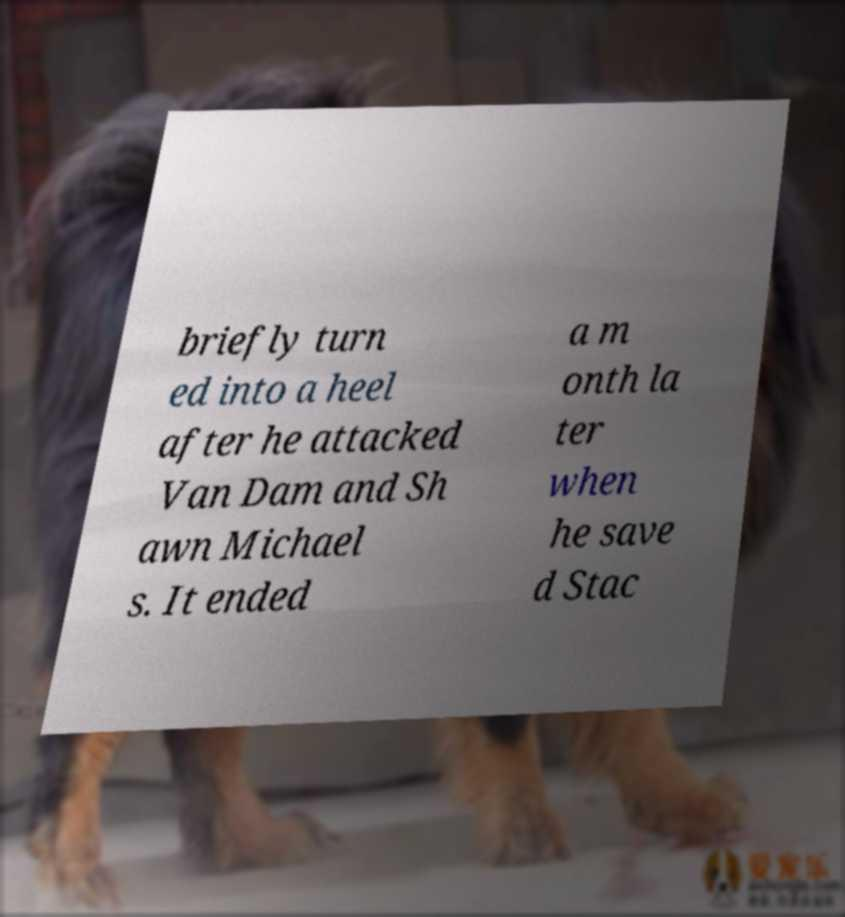There's text embedded in this image that I need extracted. Can you transcribe it verbatim? briefly turn ed into a heel after he attacked Van Dam and Sh awn Michael s. It ended a m onth la ter when he save d Stac 